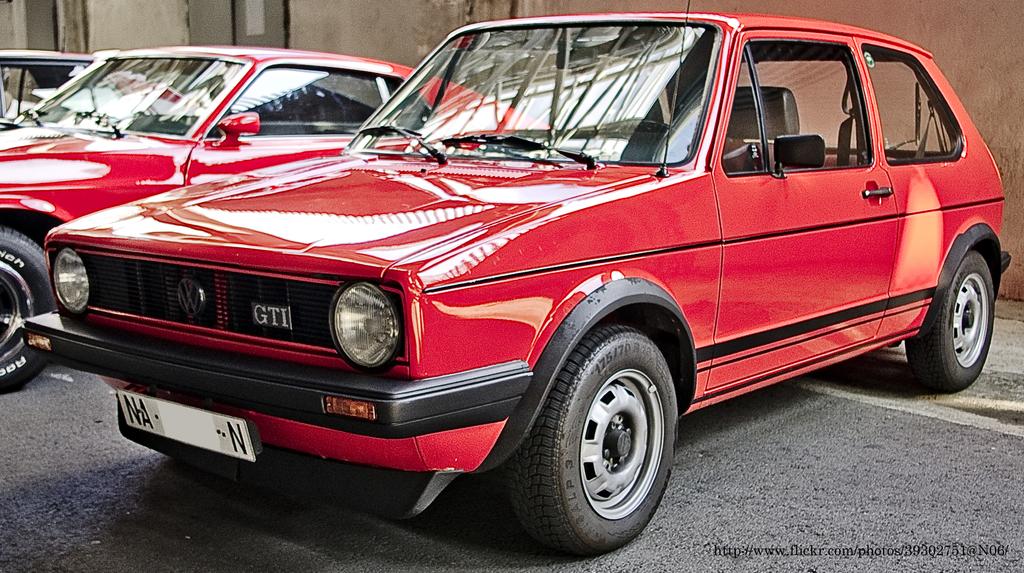What model is the car?
Provide a succinct answer. Gti. What is on the grille?
Your answer should be compact. Gti. 